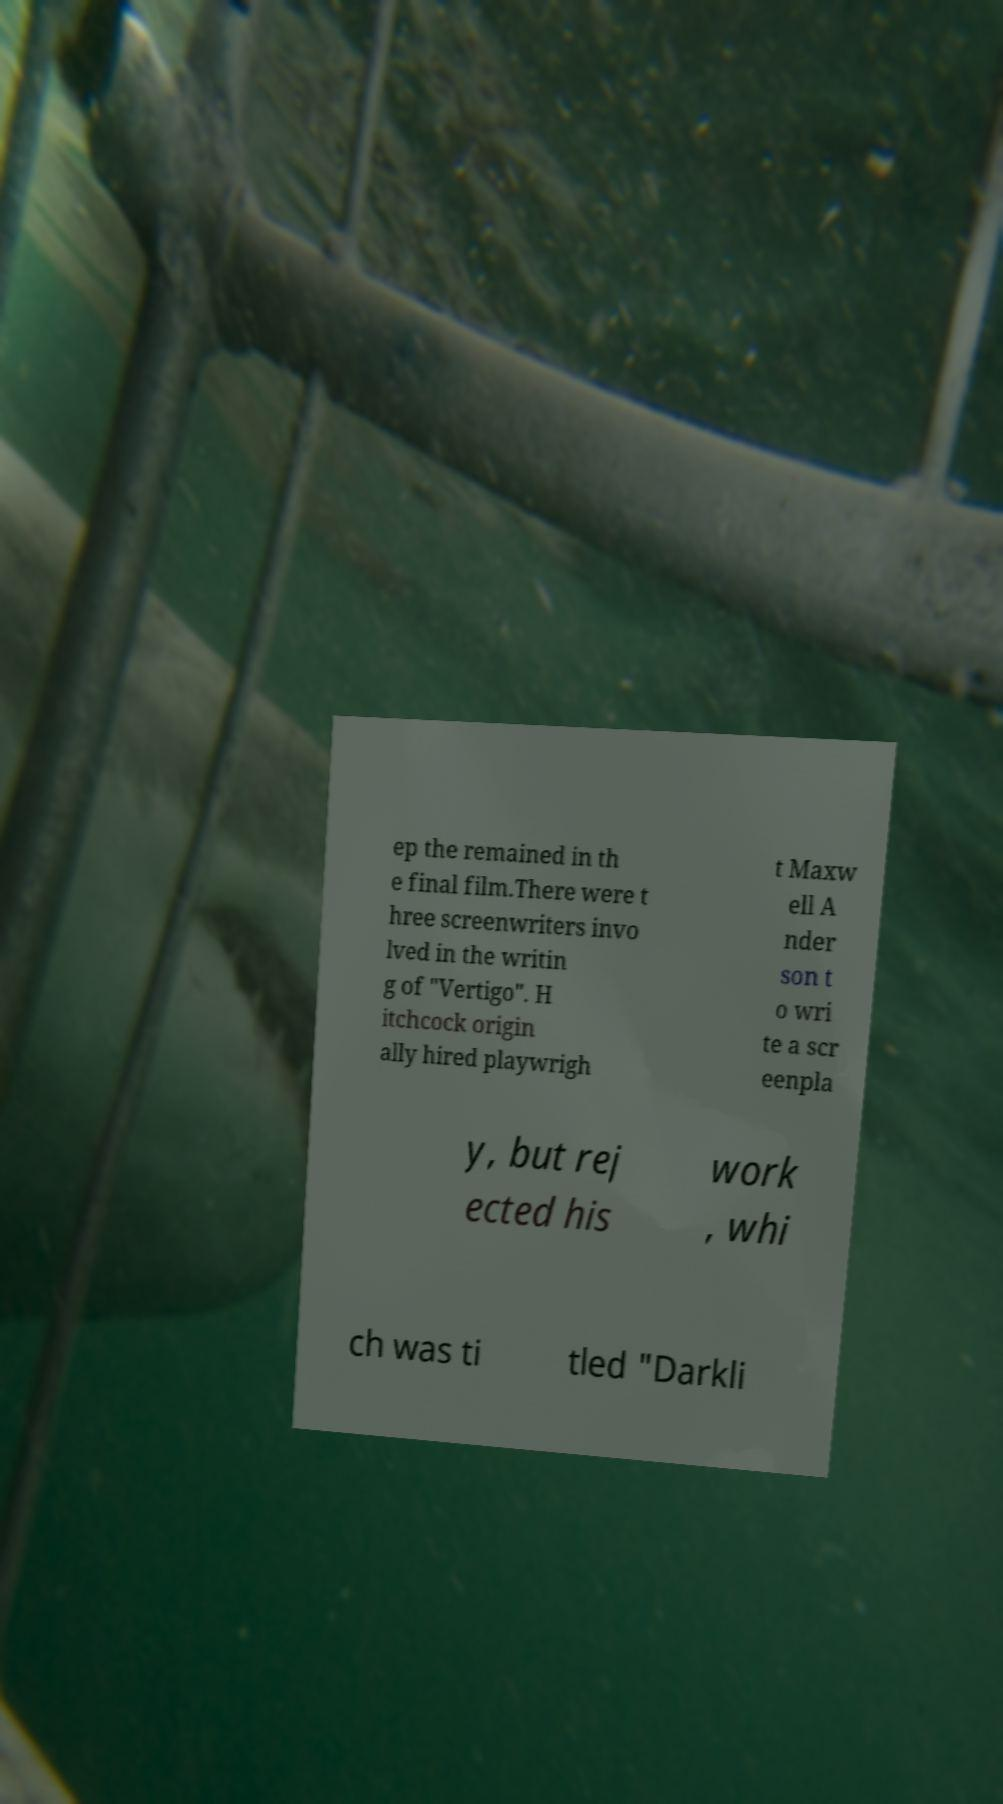For documentation purposes, I need the text within this image transcribed. Could you provide that? ep the remained in th e final film.There were t hree screenwriters invo lved in the writin g of "Vertigo". H itchcock origin ally hired playwrigh t Maxw ell A nder son t o wri te a scr eenpla y, but rej ected his work , whi ch was ti tled "Darkli 